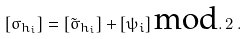<formula> <loc_0><loc_0><loc_500><loc_500>[ \sigma _ { h _ { i } } ] = [ \tilde { \sigma } _ { h _ { i } } ] + [ \psi _ { i } ] \, \text {mod} . \, 2 \, .</formula> 